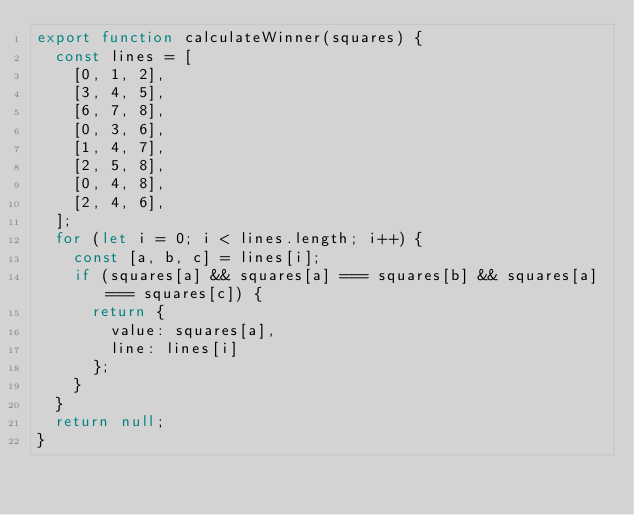<code> <loc_0><loc_0><loc_500><loc_500><_JavaScript_>export function calculateWinner(squares) {
  const lines = [
    [0, 1, 2],
    [3, 4, 5],
    [6, 7, 8],
    [0, 3, 6],
    [1, 4, 7],
    [2, 5, 8],
    [0, 4, 8],
    [2, 4, 6],
  ];
  for (let i = 0; i < lines.length; i++) {
    const [a, b, c] = lines[i];
    if (squares[a] && squares[a] === squares[b] && squares[a] === squares[c]) {
      return {
        value: squares[a],
        line: lines[i]
      };
    }
  }
  return null;
}
</code> 